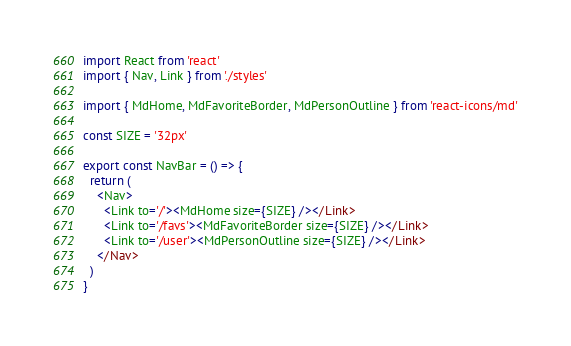<code> <loc_0><loc_0><loc_500><loc_500><_JavaScript_>import React from 'react'
import { Nav, Link } from './styles'

import { MdHome, MdFavoriteBorder, MdPersonOutline } from 'react-icons/md'

const SIZE = '32px'

export const NavBar = () => {
  return (
    <Nav>
      <Link to='/'><MdHome size={SIZE} /></Link>
      <Link to='/favs'><MdFavoriteBorder size={SIZE} /></Link>
      <Link to='/user'><MdPersonOutline size={SIZE} /></Link>
    </Nav>
  )
}
</code> 